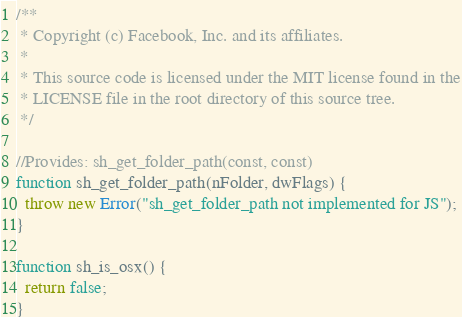Convert code to text. <code><loc_0><loc_0><loc_500><loc_500><_JavaScript_>/**
 * Copyright (c) Facebook, Inc. and its affiliates.
 *
 * This source code is licensed under the MIT license found in the
 * LICENSE file in the root directory of this source tree.
 */

//Provides: sh_get_folder_path(const, const)
function sh_get_folder_path(nFolder, dwFlags) {
  throw new Error("sh_get_folder_path not implemented for JS");
}

function sh_is_osx() {
  return false;
}
</code> 